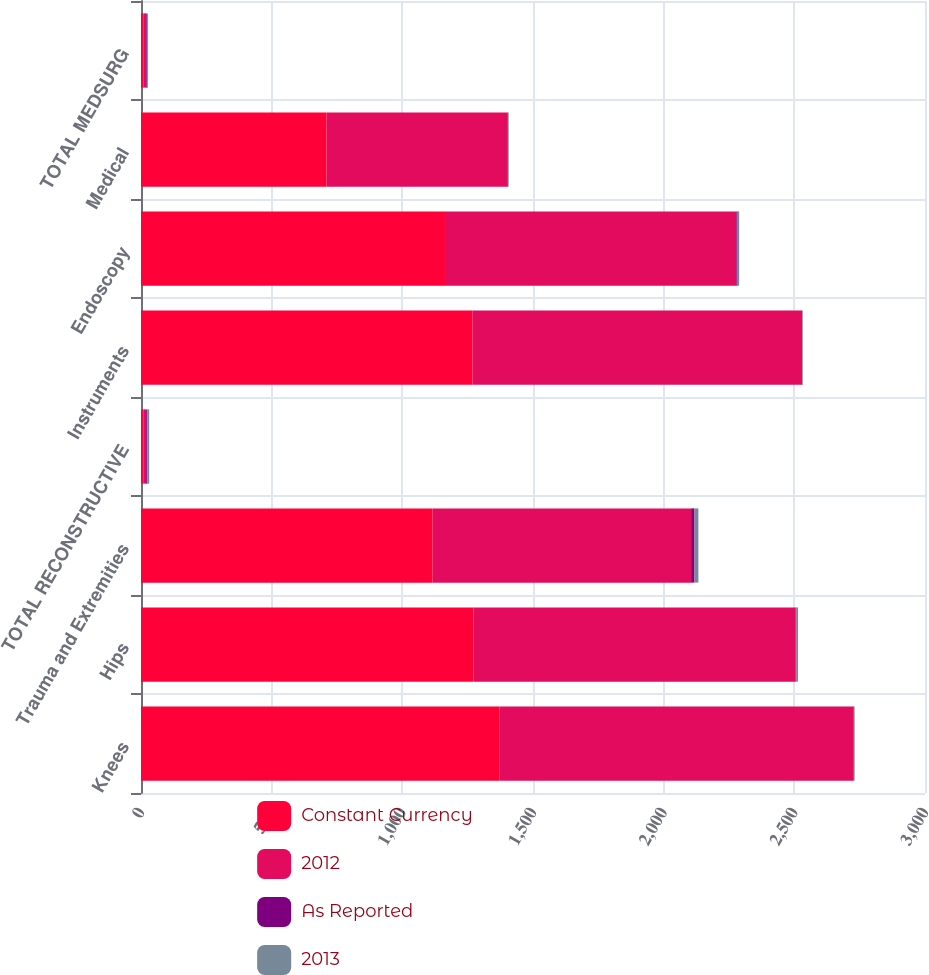Convert chart to OTSL. <chart><loc_0><loc_0><loc_500><loc_500><stacked_bar_chart><ecel><fcel>Knees<fcel>Hips<fcel>Trauma and Extremities<fcel>TOTAL RECONSTRUCTIVE<fcel>Instruments<fcel>Endoscopy<fcel>Medical<fcel>TOTAL MEDSURG<nl><fcel>Constant Currency<fcel>1371<fcel>1272<fcel>1116<fcel>9.85<fcel>1269<fcel>1167<fcel>710<fcel>9.85<nl><fcel>2012<fcel>1356<fcel>1233<fcel>989<fcel>9.85<fcel>1261<fcel>1111<fcel>691<fcel>9.85<nl><fcel>As Reported<fcel>1.1<fcel>3.2<fcel>12.8<fcel>4.8<fcel>0.6<fcel>5<fcel>2.8<fcel>2.9<nl><fcel>2013<fcel>2.6<fcel>6<fcel>15.1<fcel>6.9<fcel>1.9<fcel>6<fcel>3.1<fcel>3.8<nl></chart> 